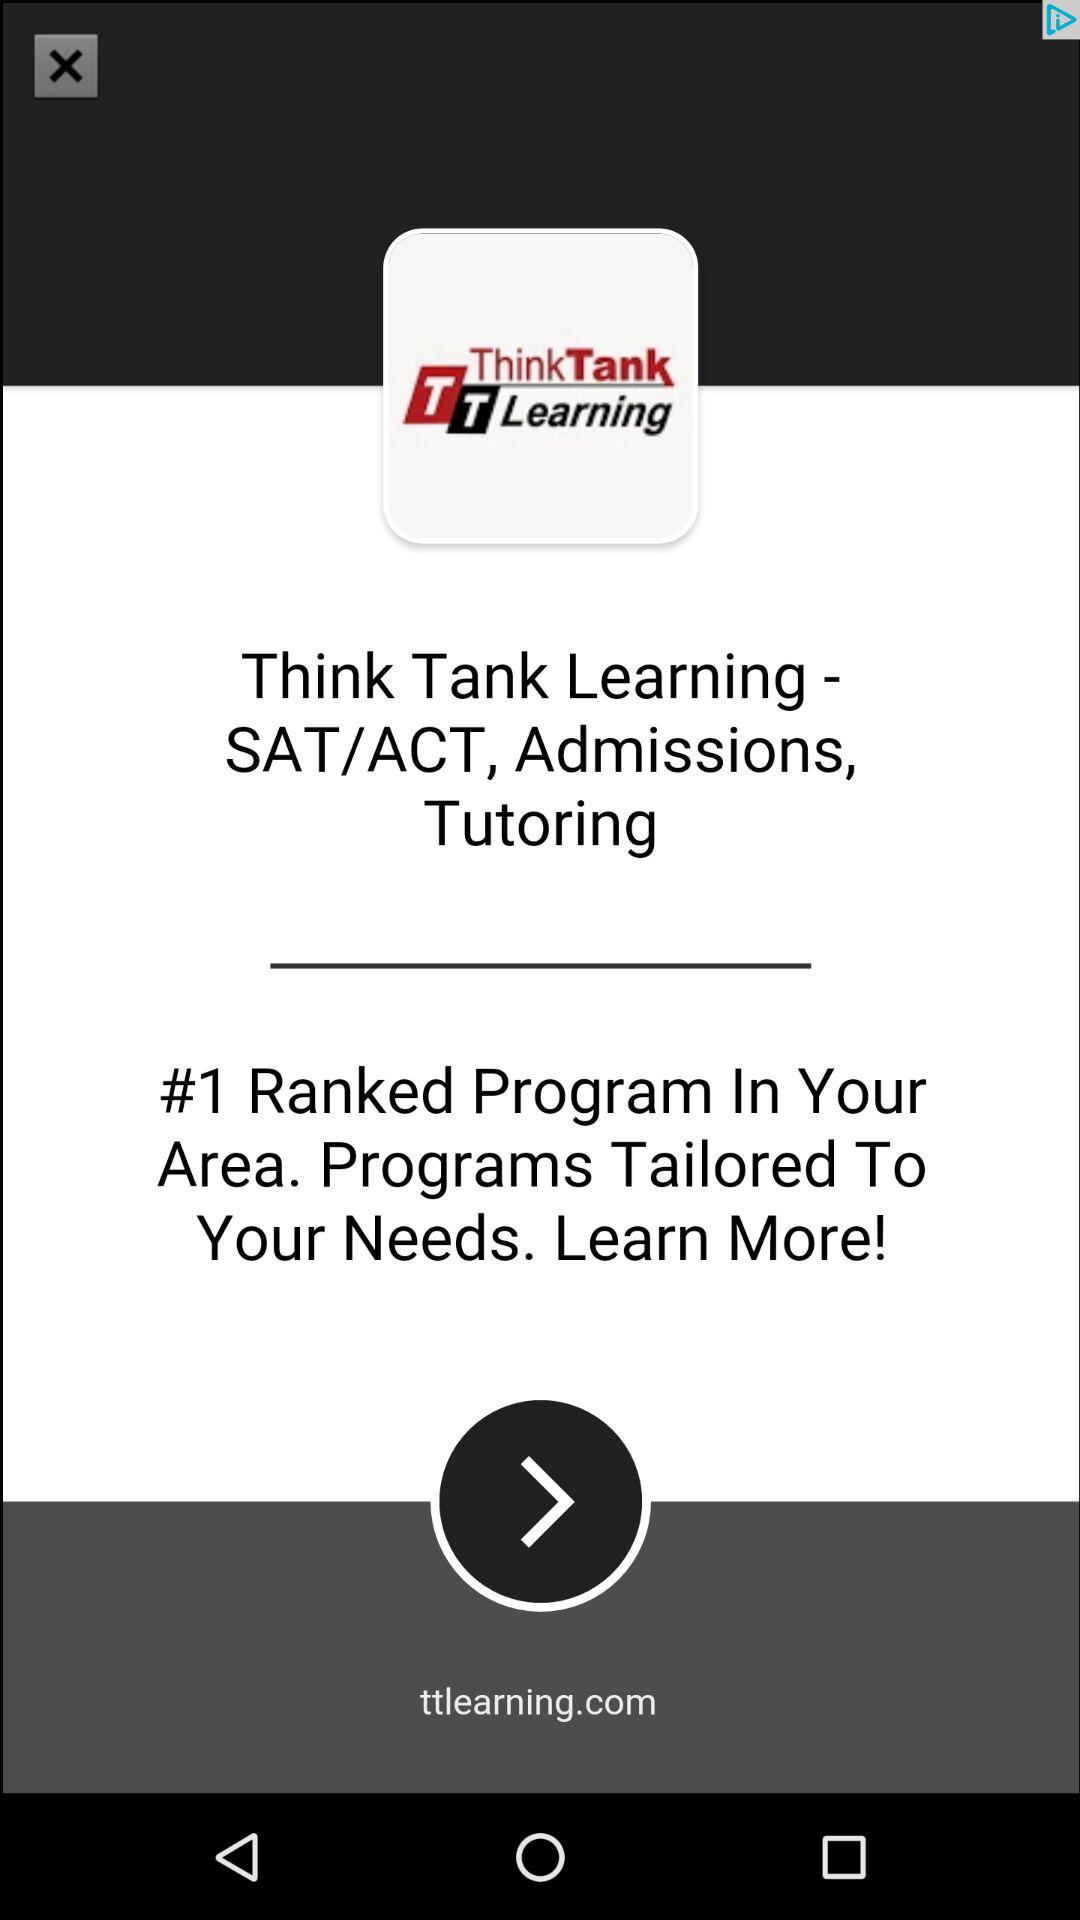What is the Think Tank Learning application for? The application is for SAT/ACT, Admissions, and Tutoring. 